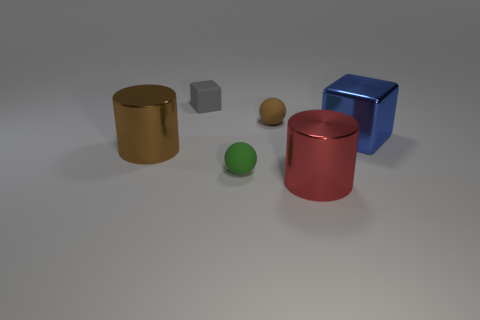There is a tiny matte thing that is in front of the brown sphere; does it have the same shape as the brown thing that is behind the large brown cylinder?
Give a very brief answer. Yes. Is there a small brown matte thing that is behind the large thing behind the big shiny thing on the left side of the big red object?
Your answer should be compact. Yes. Is the material of the tiny gray cube the same as the small brown ball?
Keep it short and to the point. Yes. What is the material of the ball that is behind the ball that is in front of the blue thing?
Make the answer very short. Rubber. What size is the red shiny cylinder that is in front of the blue metallic cube?
Ensure brevity in your answer.  Large. What color is the object that is both on the left side of the red shiny cylinder and to the right of the green thing?
Give a very brief answer. Brown. There is a brown object to the left of the gray thing; does it have the same size as the big blue cube?
Provide a short and direct response. Yes. Are there any matte spheres that are behind the big metal object that is left of the tiny brown rubber sphere?
Ensure brevity in your answer.  Yes. What material is the brown sphere?
Your answer should be very brief. Rubber. Are there any small objects behind the blue shiny thing?
Your answer should be very brief. Yes. 